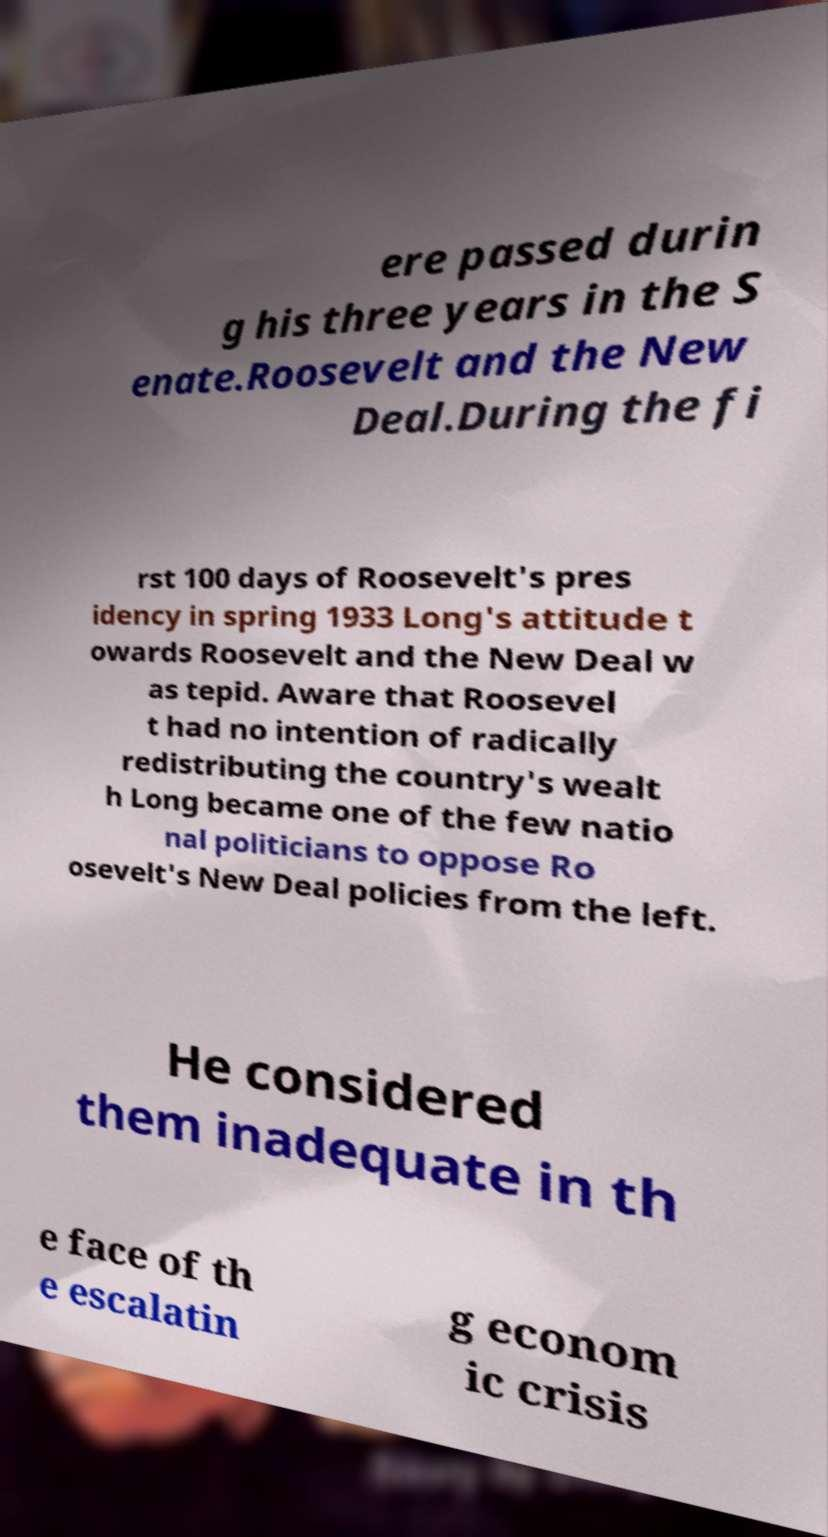I need the written content from this picture converted into text. Can you do that? ere passed durin g his three years in the S enate.Roosevelt and the New Deal.During the fi rst 100 days of Roosevelt's pres idency in spring 1933 Long's attitude t owards Roosevelt and the New Deal w as tepid. Aware that Roosevel t had no intention of radically redistributing the country's wealt h Long became one of the few natio nal politicians to oppose Ro osevelt's New Deal policies from the left. He considered them inadequate in th e face of th e escalatin g econom ic crisis 